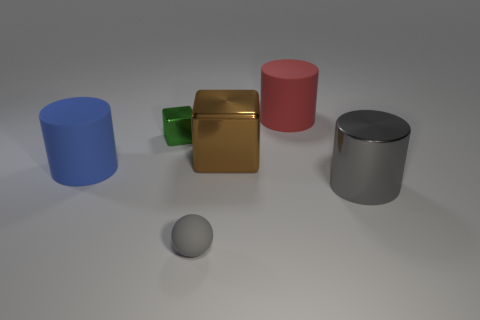Is there a small green object that has the same material as the large gray cylinder?
Give a very brief answer. Yes. Is the shape of the red object the same as the big rubber object in front of the small green thing?
Make the answer very short. Yes. There is a blue matte thing; are there any large red things in front of it?
Your response must be concise. No. What number of tiny matte things have the same shape as the large blue object?
Your answer should be compact. 0. Is the gray ball made of the same material as the gray object that is on the right side of the tiny ball?
Offer a terse response. No. How many large cylinders are there?
Your answer should be compact. 3. There is a metal cube that is behind the big brown metallic object; what is its size?
Offer a very short reply. Small. What number of red matte things are the same size as the blue cylinder?
Offer a terse response. 1. What is the large cylinder that is both on the right side of the tiny gray ball and in front of the large red object made of?
Offer a very short reply. Metal. What is the material of the brown object that is the same size as the red cylinder?
Keep it short and to the point. Metal. 